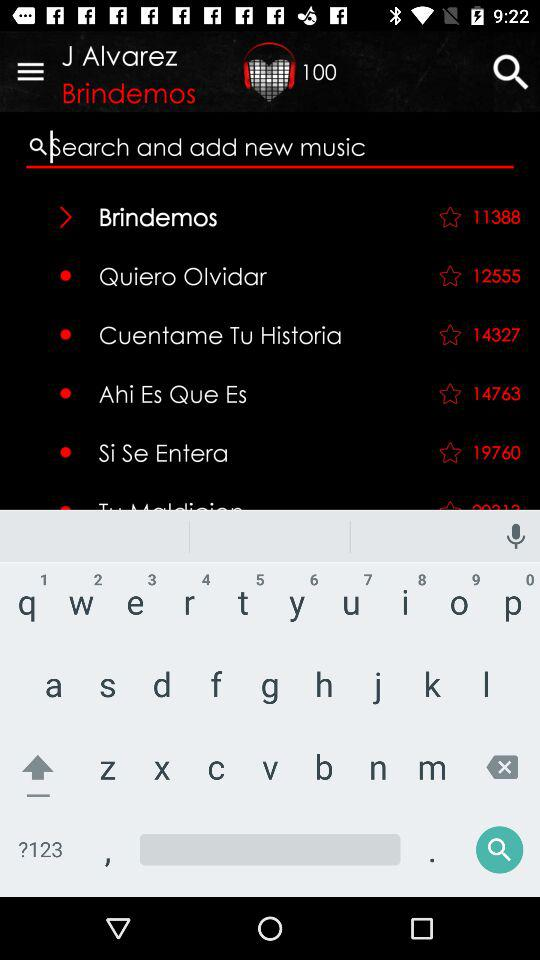How many fans have rated this video?
Answer the question using a single word or phrase. 3 